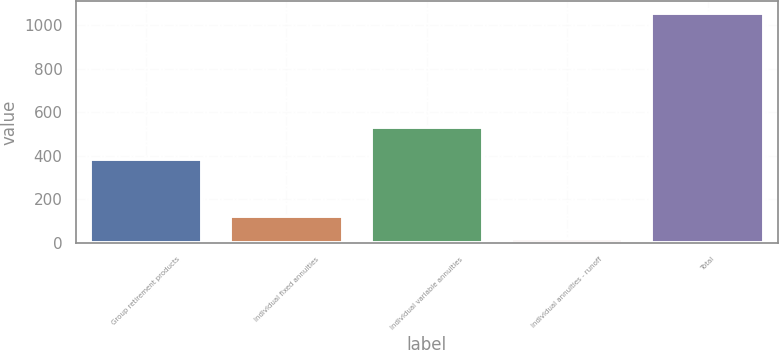<chart> <loc_0><loc_0><loc_500><loc_500><bar_chart><fcel>Group retirement products<fcel>Individual fixed annuities<fcel>Individual variable annuities<fcel>Individual annuities - runoff<fcel>Total<nl><fcel>386<fcel>122<fcel>531<fcel>18<fcel>1057<nl></chart> 